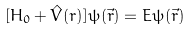Convert formula to latex. <formula><loc_0><loc_0><loc_500><loc_500>[ H _ { 0 } + { \hat { V } ( r ) } ] \psi ( \vec { r } ) = E \psi ( \vec { r } )</formula> 